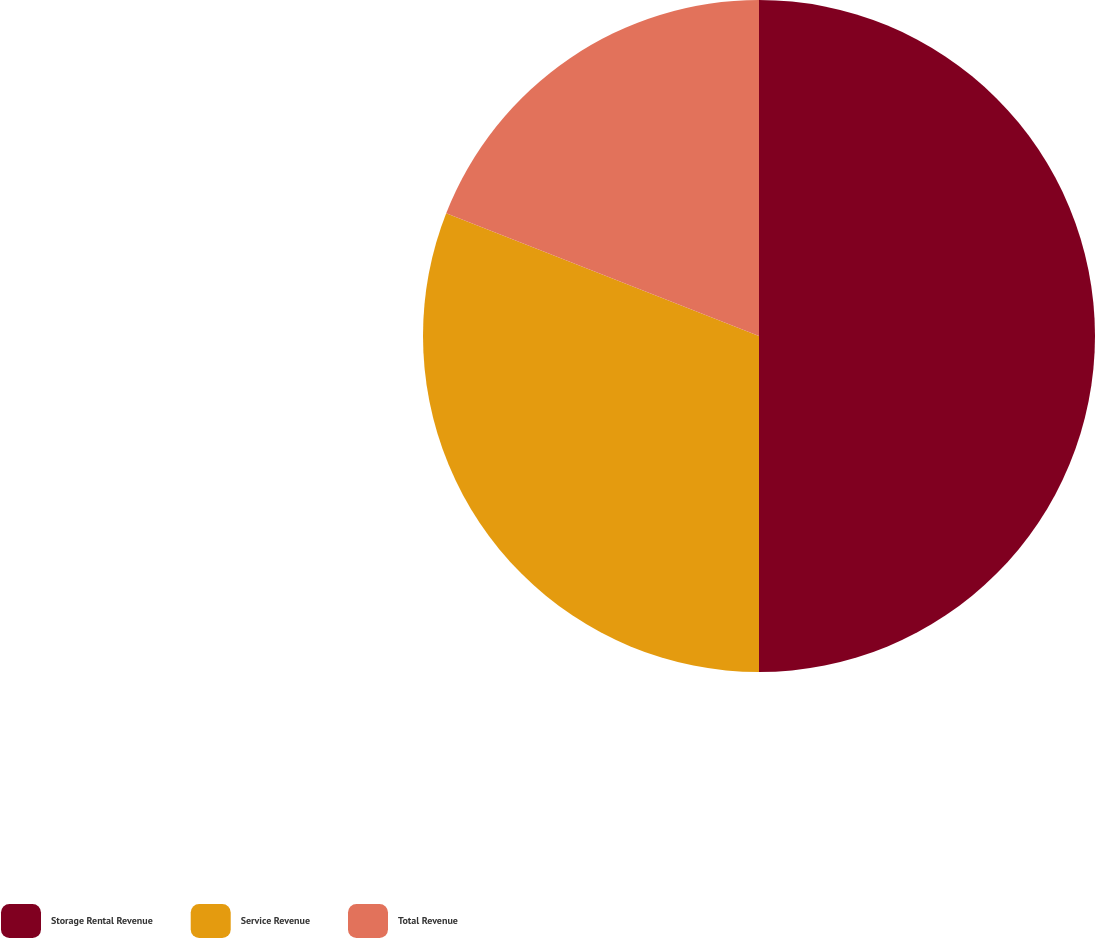Convert chart to OTSL. <chart><loc_0><loc_0><loc_500><loc_500><pie_chart><fcel>Storage Rental Revenue<fcel>Service Revenue<fcel>Total Revenue<nl><fcel>50.0%<fcel>30.95%<fcel>19.05%<nl></chart> 